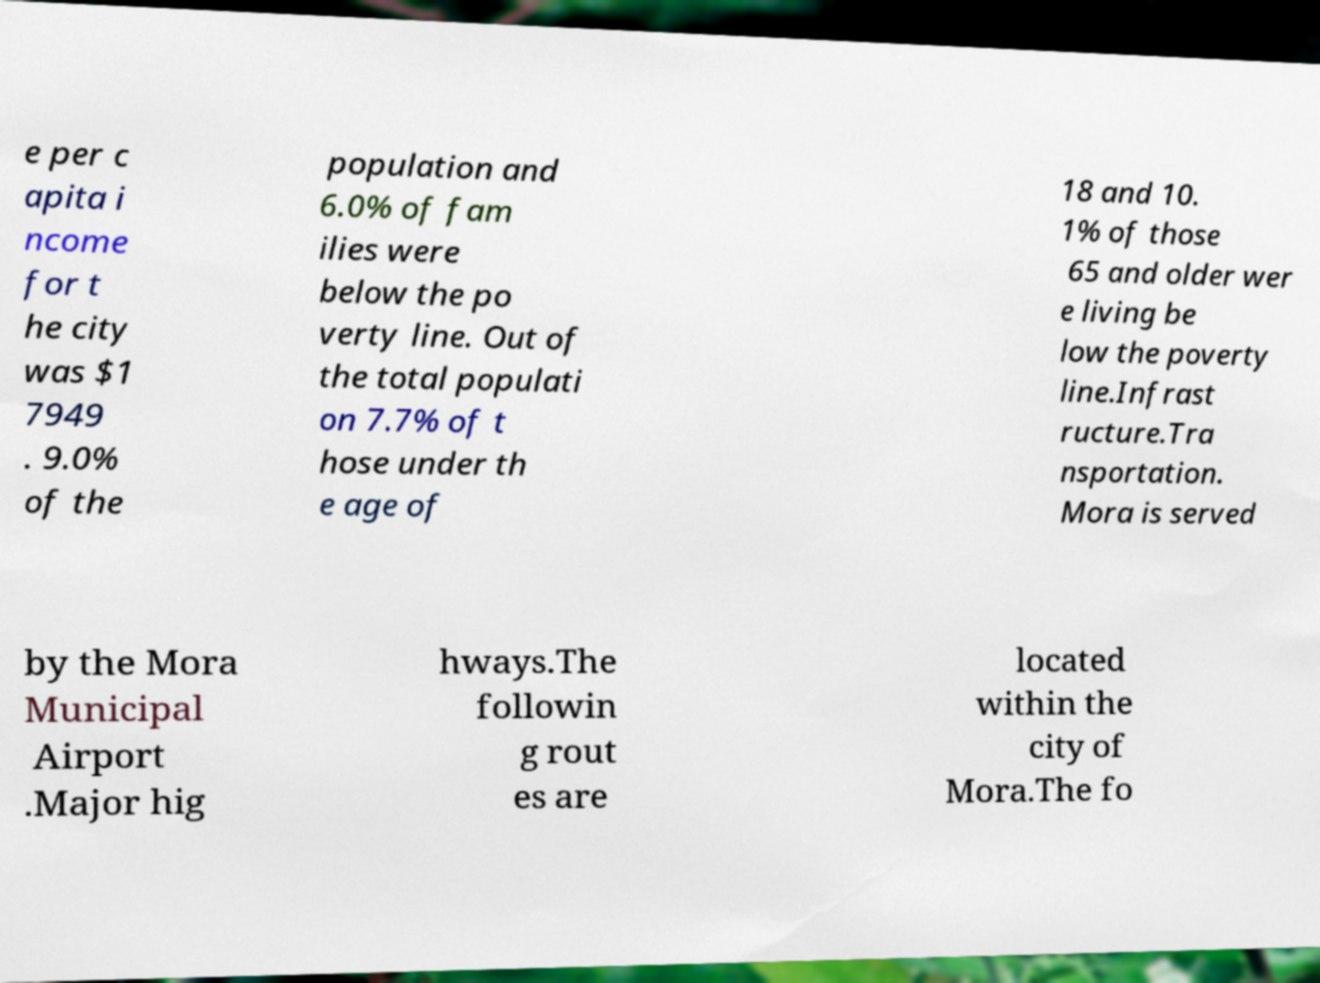Please read and relay the text visible in this image. What does it say? e per c apita i ncome for t he city was $1 7949 . 9.0% of the population and 6.0% of fam ilies were below the po verty line. Out of the total populati on 7.7% of t hose under th e age of 18 and 10. 1% of those 65 and older wer e living be low the poverty line.Infrast ructure.Tra nsportation. Mora is served by the Mora Municipal Airport .Major hig hways.The followin g rout es are located within the city of Mora.The fo 